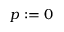<formula> <loc_0><loc_0><loc_500><loc_500>p \colon = 0</formula> 